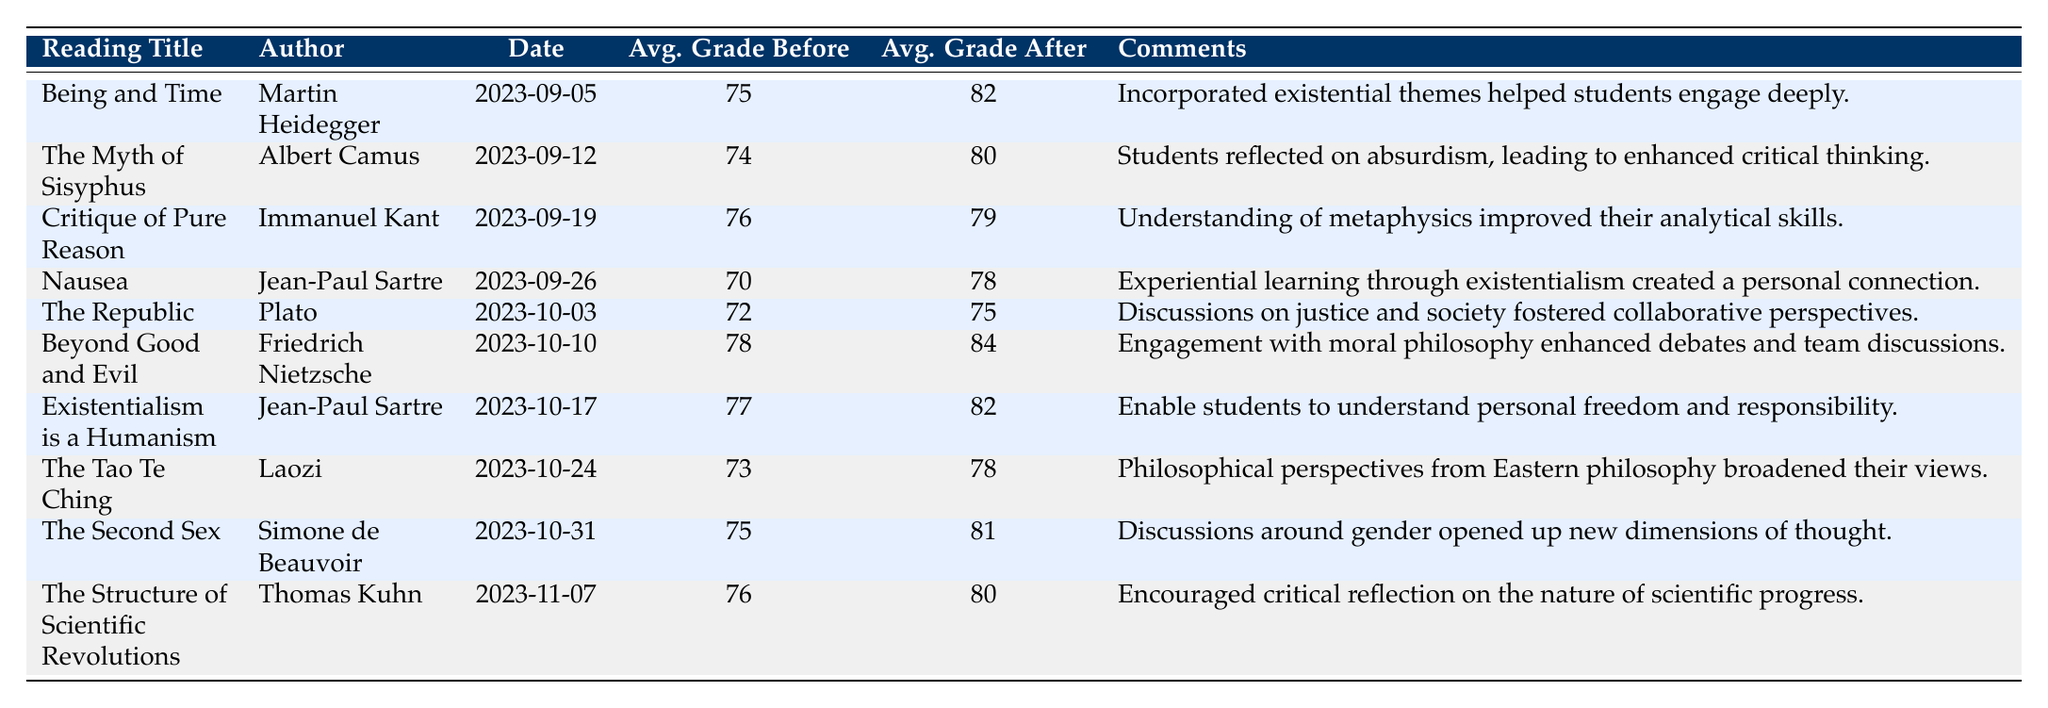What was the average grade before the reading "Nausea"? The column for average grades before each reading shows 70 for "Nausea."
Answer: 70 Which reading had the highest average grade after? By examining the average grade after each reading, "Beyond Good and Evil" has the highest average grade of 84.
Answer: 84 What is the total increase in average grades from "The Republic" to "The Structure of Scientific Revolutions"? The average grade for "The Republic" after is 75, and for "The Structure of Scientific Revolutions," it is 80. The increase is 80 - 75 = 5.
Answer: 5 Did all readings result in an improvement in students' average grades? Reviewing all readings, every reading's average grade after is higher than or equal to its average grade before, indicating that all readings led to improved performance.
Answer: Yes Which author's work led to a critical reflection on the nature of scientific progress? The work leading to this reflection is "The Structure of Scientific Revolutions," authored by Thomas Kuhn, as mentioned in the comments.
Answer: Thomas Kuhn What is the average increase in grades across all readings? The grade increases are: (82-75), (80-74), (79-76), (78-70), (75-72), (84-78), (82-77), (78-73), (81-75), (80-76) which are 7, 6, 3, 8, 3, 6, 5, 5, 6, 4. The total increase is 57, and dividing by 10 readings gives an average increase of 57/10 = 5.7.
Answer: 5.7 Which reading had the least impact on students' grades based on the increase? By comparing increases, "Critique of Pure Reason" showed the smallest increase of 3 (79 - 76).
Answer: 3 Were the comments regarding "Existentialism is a Humanism" focused on personal freedom and responsibility? The comments for "Existentialism is a Humanism" specifically mention understanding personal freedom and responsibility, confirming the focus.
Answer: Yes What reading had students engage deeply due to the incorporation of existential themes? The readings' comments indicate that "Being and Time" helped students engage deeply with existential themes.
Answer: Being and Time What was the average grade before the reading "The Second Sex"? Looking at the average before grades, "The Second Sex" shows an average of 75.
Answer: 75 